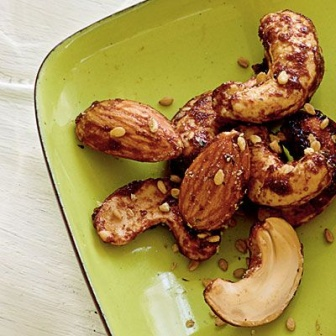What's a quick, casual description of this image? A green plate loaded with roasted cashews and almonds, sprinkled with sesharegpt4v/same seeds, sits on a white wooden surface. The nuts have a glossy finish, indicating they're freshly roasted and spiced up. 